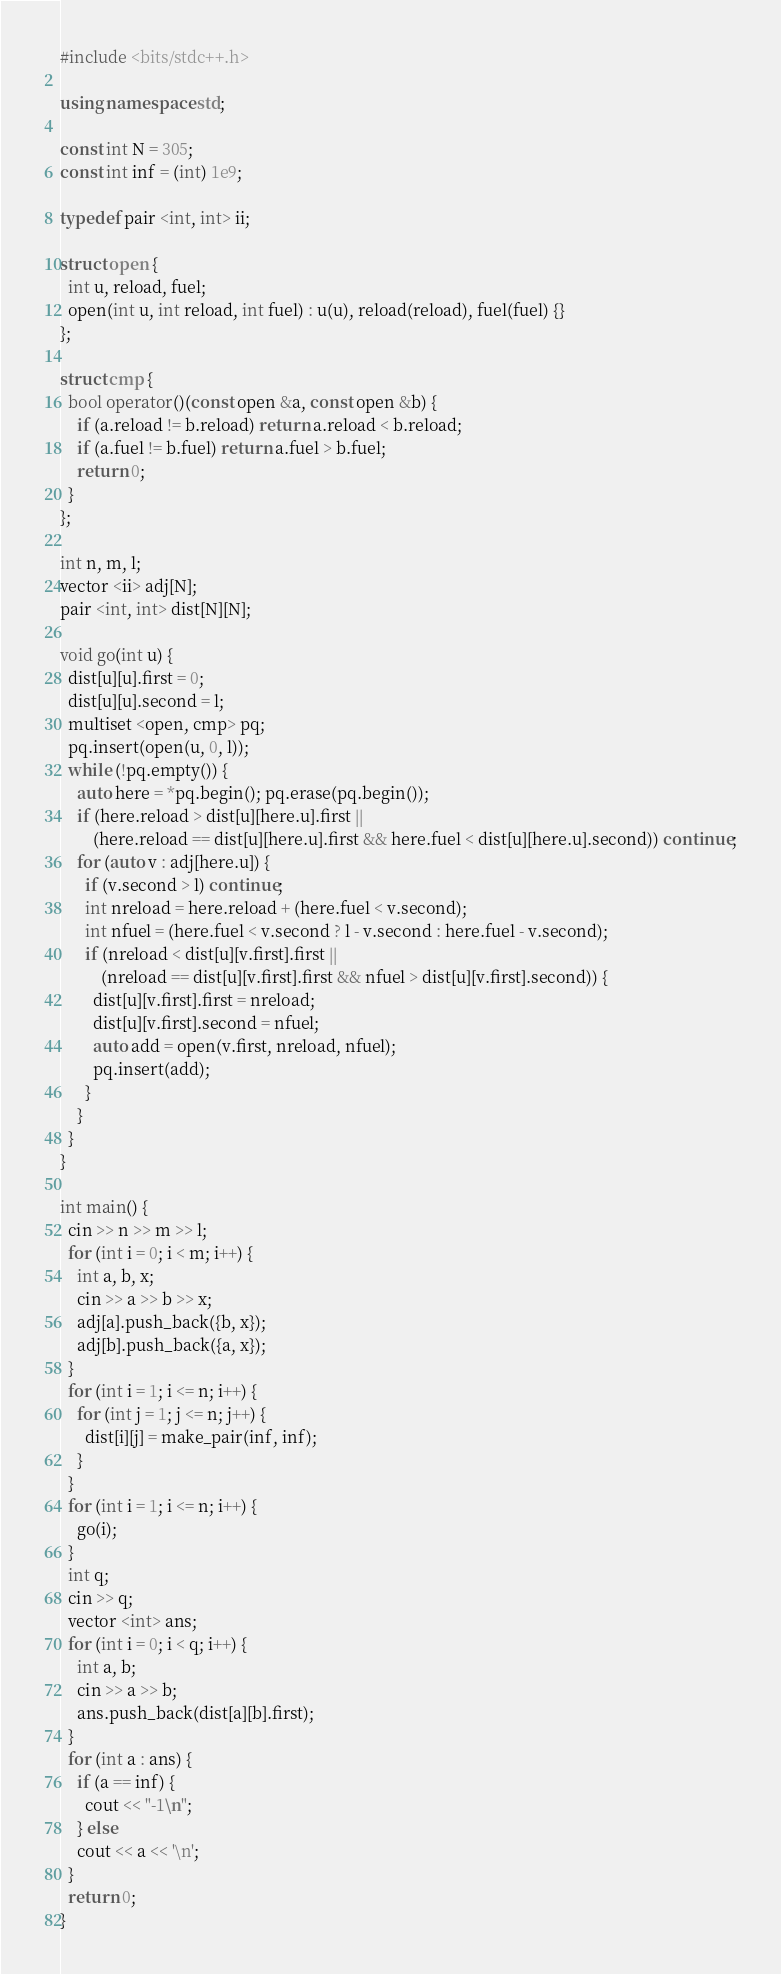<code> <loc_0><loc_0><loc_500><loc_500><_C++_>#include <bits/stdc++.h>

using namespace std;

const int N = 305;
const int inf = (int) 1e9;

typedef pair <int, int> ii;

struct open {
  int u, reload, fuel;
  open(int u, int reload, int fuel) : u(u), reload(reload), fuel(fuel) {}
};

struct cmp {
  bool operator()(const open &a, const open &b) {
    if (a.reload != b.reload) return a.reload < b.reload;
    if (a.fuel != b.fuel) return a.fuel > b.fuel;
    return 0;
  }
};

int n, m, l;
vector <ii> adj[N];
pair <int, int> dist[N][N];

void go(int u) {
  dist[u][u].first = 0;
  dist[u][u].second = l;
  multiset <open, cmp> pq;
  pq.insert(open(u, 0, l));
  while (!pq.empty()) {
    auto here = *pq.begin(); pq.erase(pq.begin());
    if (here.reload > dist[u][here.u].first ||
        (here.reload == dist[u][here.u].first && here.fuel < dist[u][here.u].second)) continue;
    for (auto v : adj[here.u]) {
      if (v.second > l) continue;
      int nreload = here.reload + (here.fuel < v.second);
      int nfuel = (here.fuel < v.second ? l - v.second : here.fuel - v.second);
      if (nreload < dist[u][v.first].first ||
          (nreload == dist[u][v.first].first && nfuel > dist[u][v.first].second)) {
        dist[u][v.first].first = nreload;
        dist[u][v.first].second = nfuel;
        auto add = open(v.first, nreload, nfuel);
        pq.insert(add);
      }
    }
  }
}

int main() {
  cin >> n >> m >> l;
  for (int i = 0; i < m; i++) {
    int a, b, x;
    cin >> a >> b >> x;
    adj[a].push_back({b, x});
    adj[b].push_back({a, x});
  }
  for (int i = 1; i <= n; i++) {
    for (int j = 1; j <= n; j++) {
      dist[i][j] = make_pair(inf, inf);
    }
  }
  for (int i = 1; i <= n; i++) {
    go(i);
  }
  int q;
  cin >> q;
  vector <int> ans;
  for (int i = 0; i < q; i++) {
    int a, b;
    cin >> a >> b;
    ans.push_back(dist[a][b].first);
  }
  for (int a : ans) {
    if (a == inf) {
      cout << "-1\n";
    } else
    cout << a << '\n';
  }
  return 0;
}
</code> 